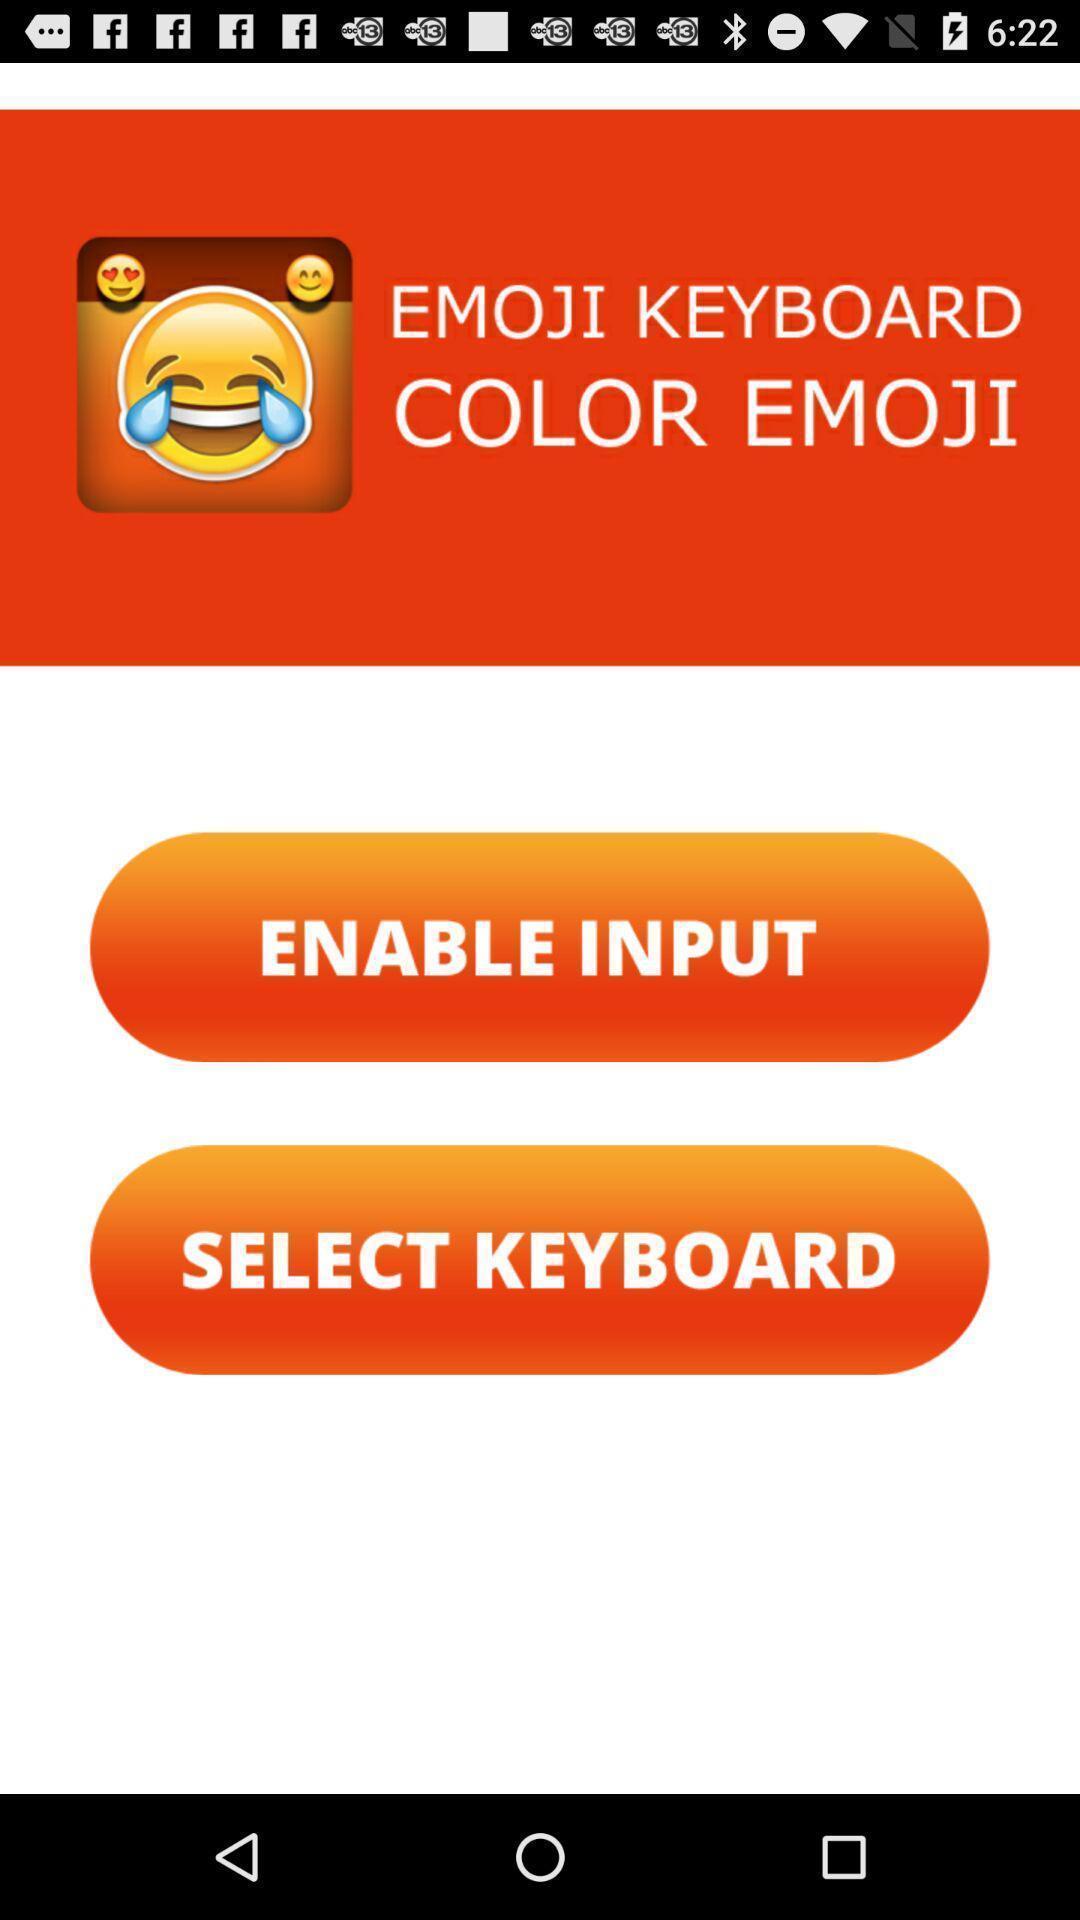Summarize the information in this screenshot. Welcome page to the application with options. 